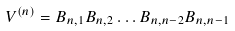Convert formula to latex. <formula><loc_0><loc_0><loc_500><loc_500>V ^ { ( n ) } = B _ { n , 1 } B _ { n , 2 } \dots B _ { n , n - 2 } B _ { n , n - 1 }</formula> 